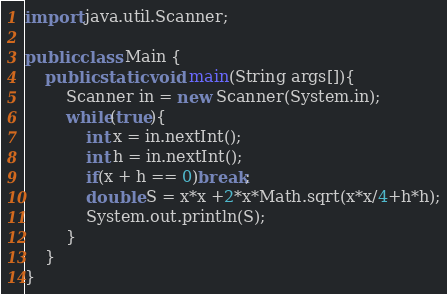Convert code to text. <code><loc_0><loc_0><loc_500><loc_500><_Java_>import java.util.Scanner;

public class Main {
	public static void main(String args[]){
		Scanner in = new Scanner(System.in);
		while(true){
			int x = in.nextInt();
			int h = in.nextInt();
			if(x + h == 0)break;
			double S = x*x +2*x*Math.sqrt(x*x/4+h*h);
			System.out.println(S);
		}
	}
}</code> 